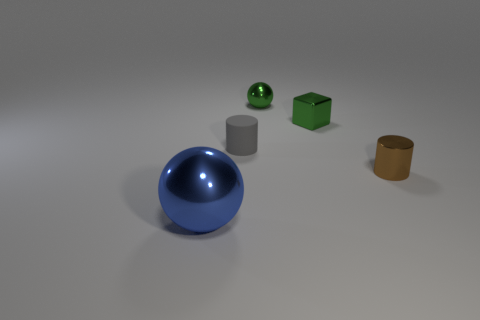Add 5 green metal things. How many objects exist? 10 Subtract all cylinders. How many objects are left? 3 Subtract 1 cylinders. How many cylinders are left? 1 Add 3 small brown cylinders. How many small brown cylinders exist? 4 Subtract 1 gray cylinders. How many objects are left? 4 Subtract all gray cylinders. Subtract all blue blocks. How many cylinders are left? 1 Subtract all green spheres. Subtract all small brown cylinders. How many objects are left? 3 Add 5 spheres. How many spheres are left? 7 